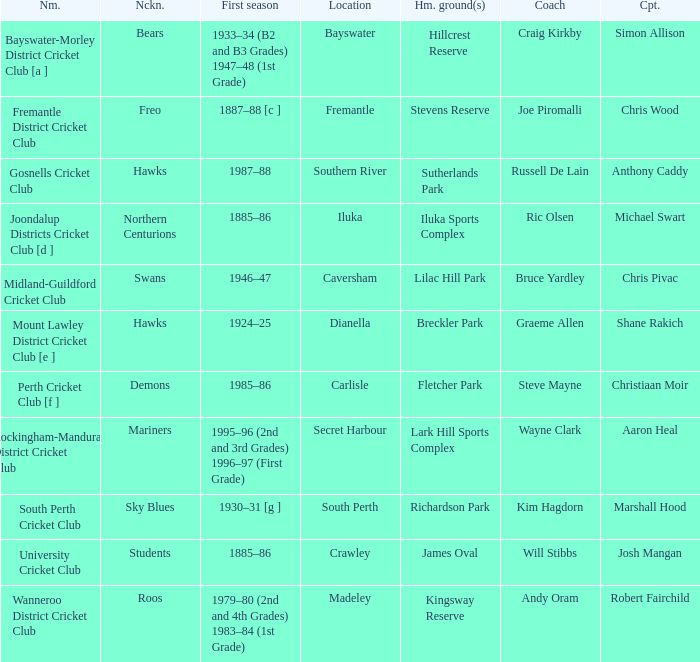What's the place for the club called the bears? Bayswater. 